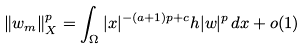<formula> <loc_0><loc_0><loc_500><loc_500>\| w _ { m } \| _ { X } ^ { p } = \int _ { \Omega } | x | ^ { - ( a + 1 ) p + c } h | w | ^ { p } \, d x + o ( 1 )</formula> 